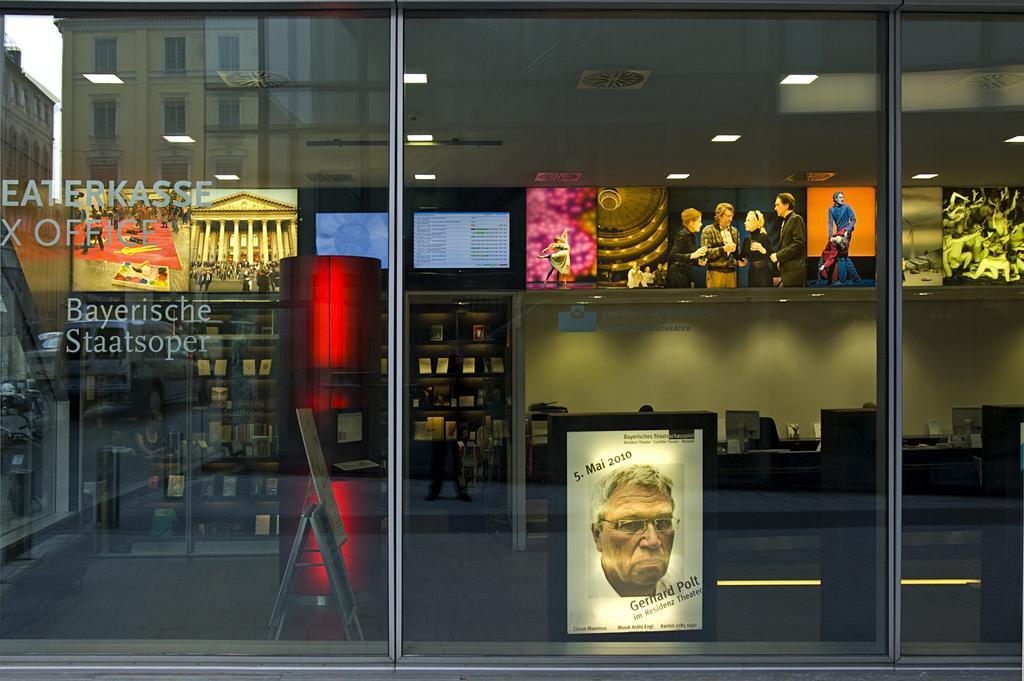How would you summarize this image in a sentence or two? In this image in the center there is a glass and behind the glass there are shelves and on the shelfs there are objects and at the top there are screens and in the center there are monitors and there are persons visible and there are objects which are red in colour and there is a board with some text and image and in the background there are buildings. On the top there are lights and on the left side of the glass there is some text written on the glass. 